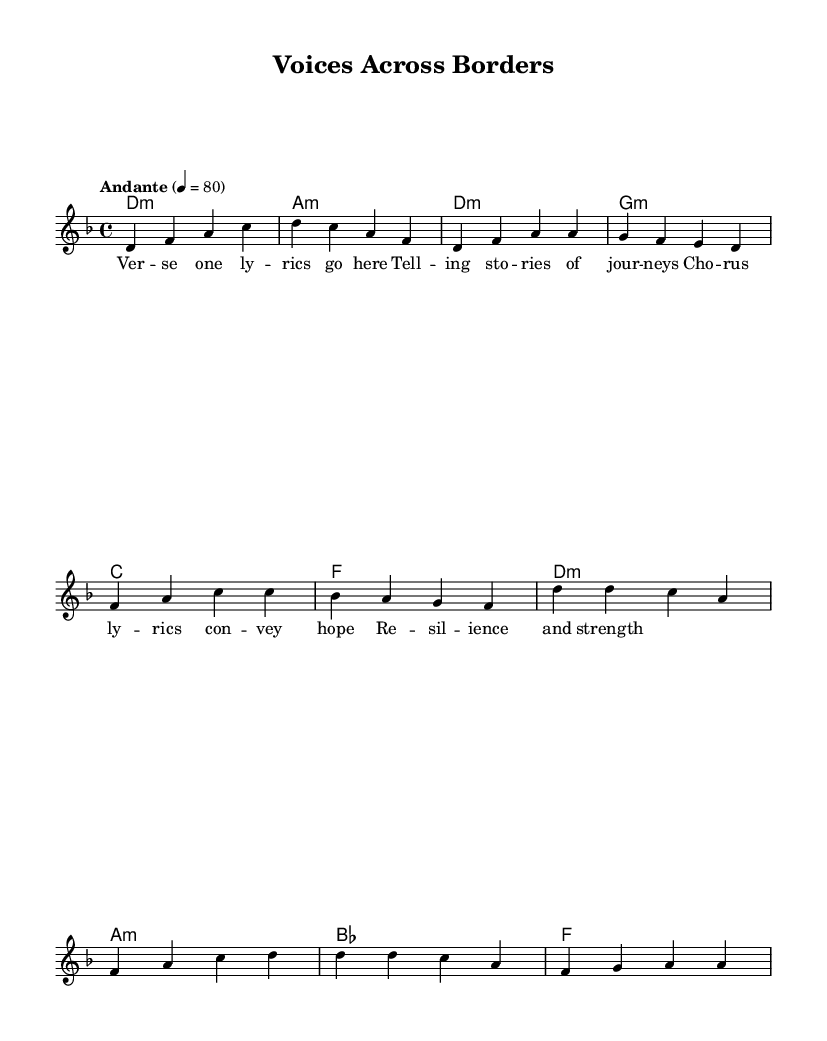What is the key signature of this music? The key signature is D minor, which has one flat (B flat). This is determined by looking at the key signature section at the beginning of the sheet music.
Answer: D minor What is the time signature of the piece? The time signature is 4/4, which means there are four beats in each measure and a quarter note gets one beat. This can be found at the beginning of the score, indicated by the numerator and denominator.
Answer: 4/4 What is the tempo marking given in the music? The tempo marking is Andante, which indicates a moderate pace. This is found above the staff at the start of the piece, where the tempo is noted.
Answer: Andante How many measures are in the given melody? The melody consists of 8 measures, counted by the groups of notes and bars between each vertical line (bar line) in the music.
Answer: 8 What is the primary theme conveyed in the lyrics of the song? The primary theme is about resilience and strength through storytelling and journeys, as indicated by the placeholder lyrics provided in the lyrics section.
Answer: Resilience and strength Which chord is played in the first measure? The chord played in the first measure is D minor, indicated by the chord notation written above the staff at the start of the piece.
Answer: D minor What type of musical composition is "Voices Across Borders"? This composition is a contemporary world music piece that incorporates refugee voices and stories, evident from the title and thematic elements suggested in the lyrics.
Answer: Contemporary world music 